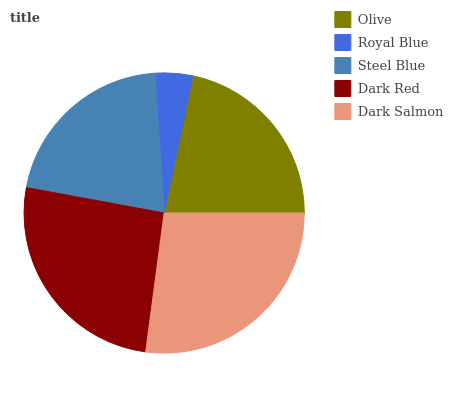Is Royal Blue the minimum?
Answer yes or no. Yes. Is Dark Salmon the maximum?
Answer yes or no. Yes. Is Steel Blue the minimum?
Answer yes or no. No. Is Steel Blue the maximum?
Answer yes or no. No. Is Steel Blue greater than Royal Blue?
Answer yes or no. Yes. Is Royal Blue less than Steel Blue?
Answer yes or no. Yes. Is Royal Blue greater than Steel Blue?
Answer yes or no. No. Is Steel Blue less than Royal Blue?
Answer yes or no. No. Is Olive the high median?
Answer yes or no. Yes. Is Olive the low median?
Answer yes or no. Yes. Is Dark Salmon the high median?
Answer yes or no. No. Is Dark Red the low median?
Answer yes or no. No. 